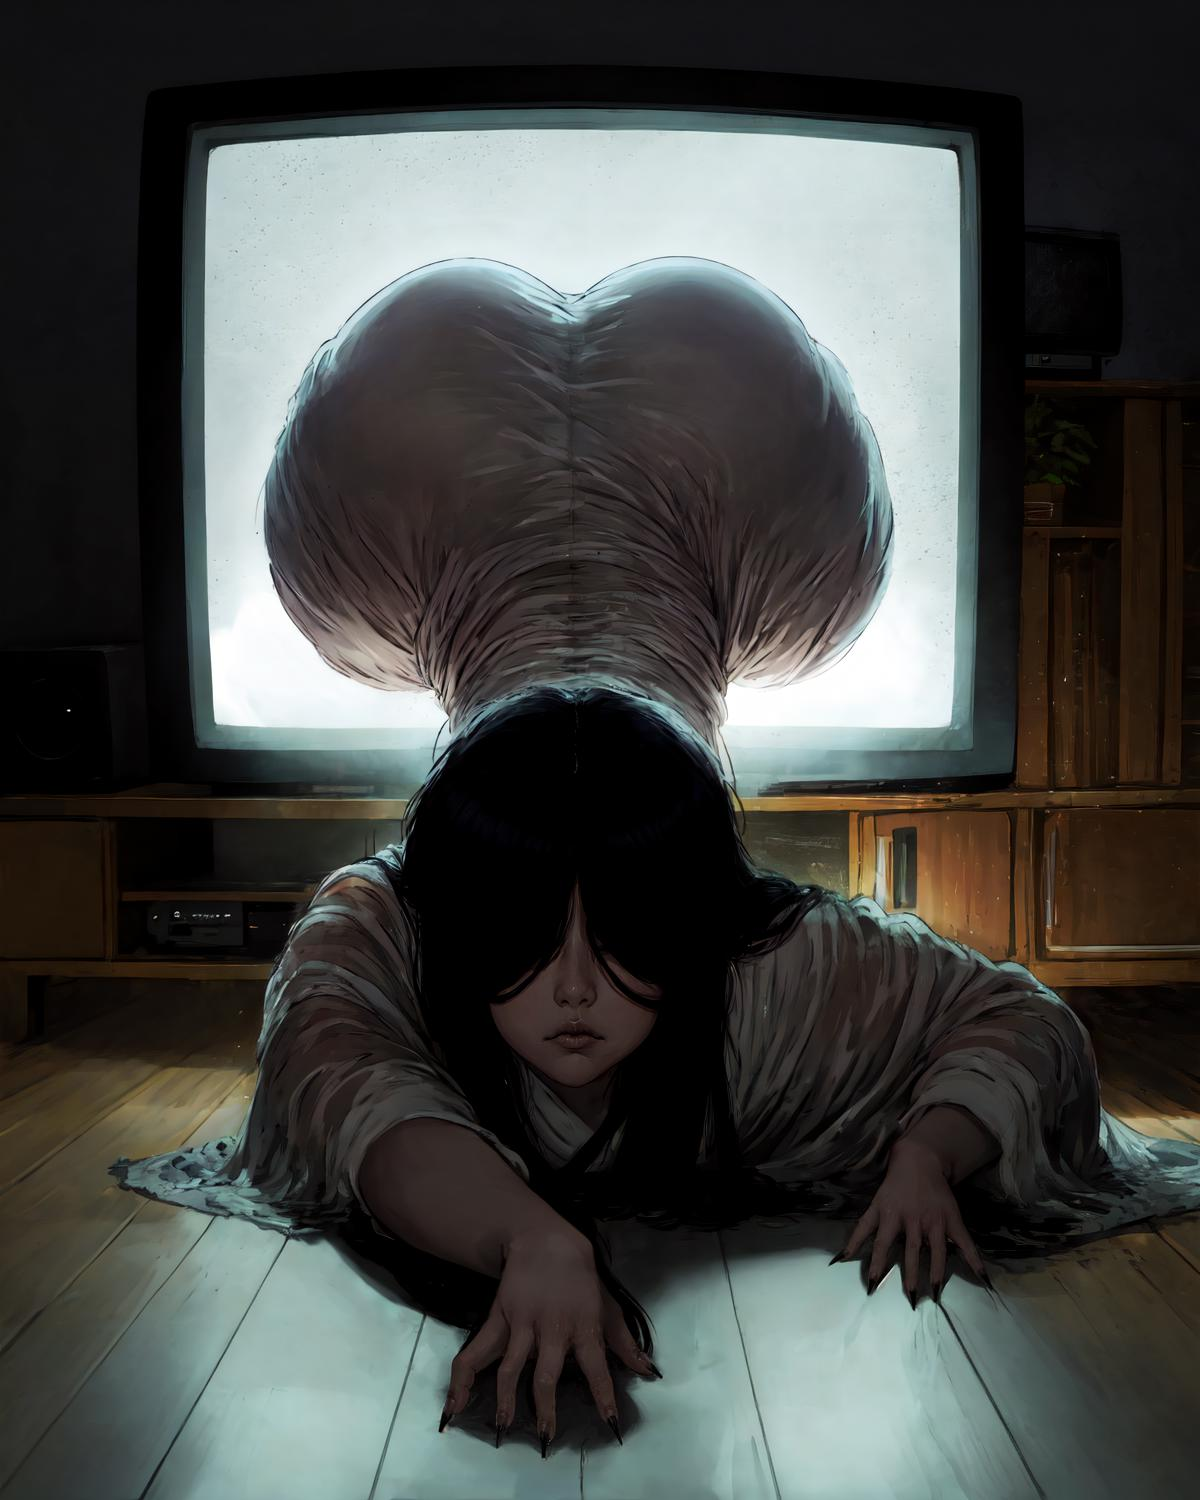describe this image
 This image depicts a surreal and unsettling scene. It shows a young girl lying on the floor in front of an old, illuminated television screen. However, her hair extends out in an unnaturally long and worm-like shape, forming a heart on the TV screen. The girl appears vulnerable and small compared to the massive, sinister-looking mass of hair emanating from her head. The lighting and muted colors create an eerie, haunting atmosphere. The image seems to symbolize themes of media influence, loss of innocence, or the darker aspects of human nature and psyche in a disturbing, metaphorical way. 